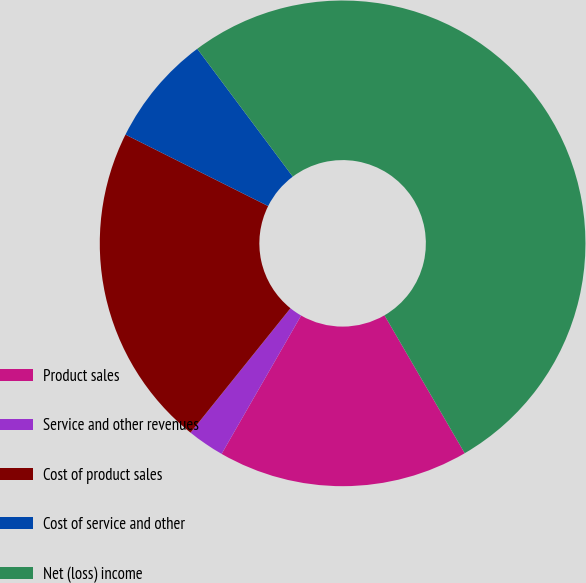Convert chart to OTSL. <chart><loc_0><loc_0><loc_500><loc_500><pie_chart><fcel>Product sales<fcel>Service and other revenues<fcel>Cost of product sales<fcel>Cost of service and other<fcel>Net (loss) income<nl><fcel>16.69%<fcel>2.47%<fcel>21.62%<fcel>7.4%<fcel>51.83%<nl></chart> 